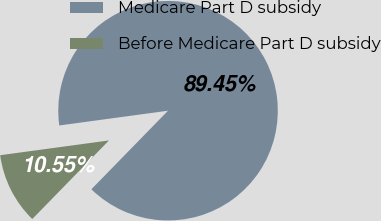Convert chart. <chart><loc_0><loc_0><loc_500><loc_500><pie_chart><fcel>Medicare Part D subsidy<fcel>Before Medicare Part D subsidy<nl><fcel>89.45%<fcel>10.55%<nl></chart> 